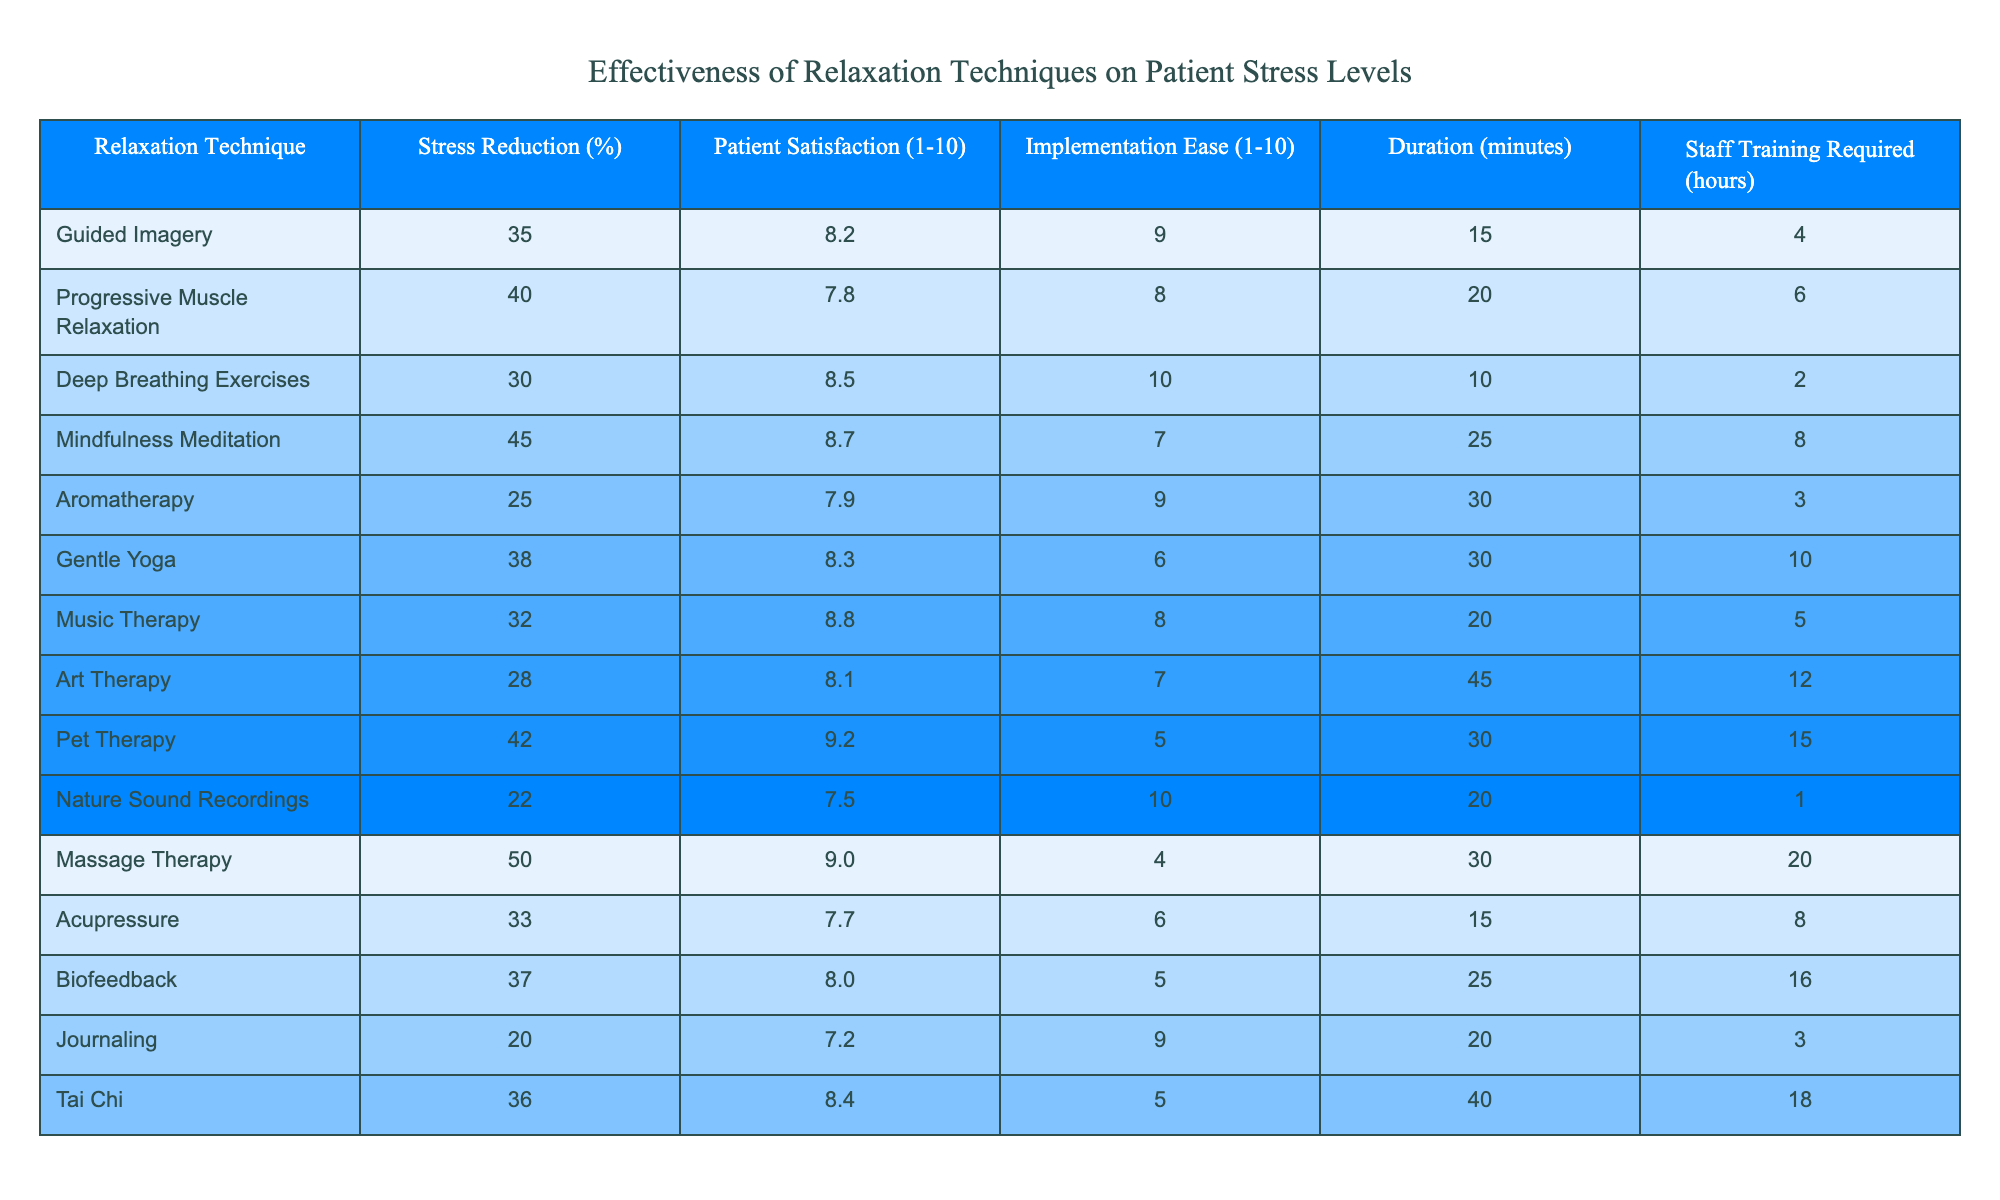What relaxation technique has the highest stress reduction percentage? The table shows that Massage Therapy has the highest stress reduction percentage at 50%.
Answer: Massage Therapy How many relaxation techniques have a patient satisfaction rating of 9 or higher? The table lists Pet Therapy and Massage Therapy, both of which have satisfaction ratings of 9.2 and 9.0, respectively. Hence, there are 2 techniques.
Answer: 2 What is the average stress reduction percentage of the relaxation techniques listed? Adding all stress reduction percentages together (35 + 40 + 30 + 45 + 25 + 38 + 32 + 28 + 42 + 22 + 50 + 33 + 37 + 20 + 36) gives us  8 techniques where the total is 615 and dividing it by 15 techniques gives an average of 41.
Answer: 41 Is there a relaxation technique that has a low implementation ease and a high patient satisfaction rating? Gentle Yoga has an implementation ease rating of 6, which is on the lower side, but it has a satisfaction rating of 8.3, which is relatively high.
Answer: Yes What is the least effective relaxation technique in terms of stress reduction? The table indicates that Journaling has the lowest stress reduction percentage at 20%.
Answer: Journaling What is the difference between the highest and lowest patient satisfaction ratings? The highest patient satisfaction rating is 9.2 (Pet Therapy), and the lowest is 7.2 (Journaling). The difference is 9.2 - 7.2 = 2.0.
Answer: 2.0 Which relaxation technique requires the least staff training hours? Nature Sound Recordings requires only 1 hour of staff training, which is the least among all techniques.
Answer: Nature Sound Recordings How many techniques take longer than 30 minutes? From the table, there are 5 techniques that take longer than 30 minutes: Gentle Yoga (30), Massage Therapy (30), Art Therapy (45), and Tai Chi (40). So, there are 4 techniques.
Answer: 4 What is the average duration of relaxation techniques that have a stress reduction percentage greater than 30%? The techniques with stress reduction percentage greater than 30% are: Guided Imagery (15), Progressive Muscle Relaxation (20), Mindfulness Meditation (25), Gentle Yoga (30), Music Therapy (20), Pet Therapy (30), Massage Therapy (30), Acupressure (15), and Tai Chi (40). Adding their durations gives 15 + 20 + 25 + 30 + 20 + 30 + 30 + 15 + 40 = 225. Dividing by 9 gives an average of 25.
Answer: 25 How many relaxation techniques have a satisfaction rating of exactly 8.3? Gentle Yoga and Music Therapy both have a satisfaction rating of exactly 8.3. Therefore, there are 2 techniques.
Answer: 2 